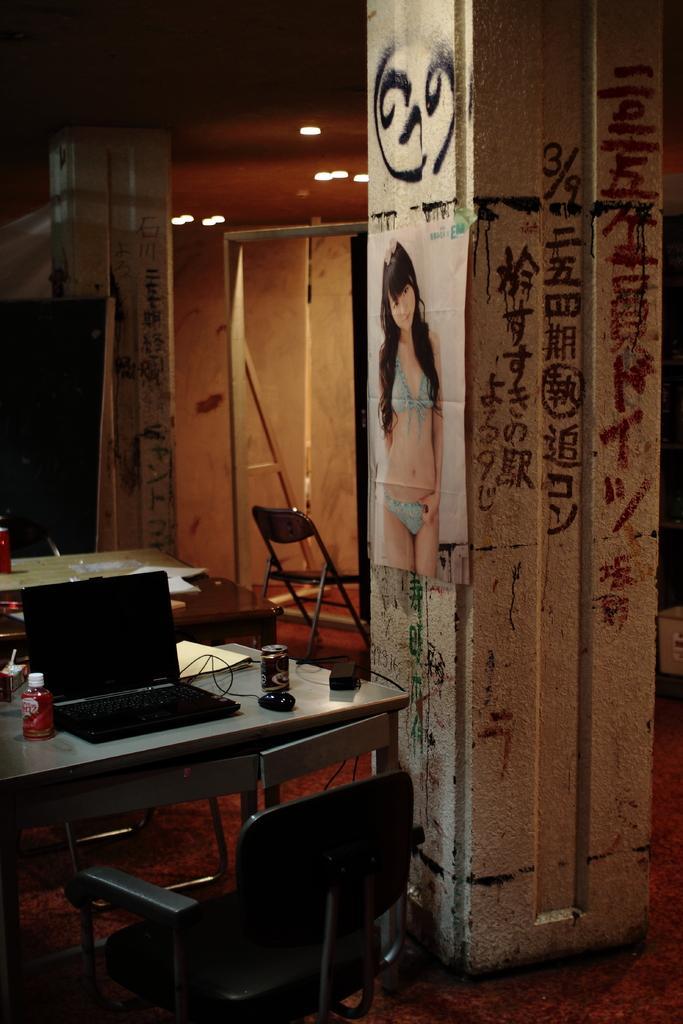Could you give a brief overview of what you see in this image? In this image, in the left side there is a table which is in white color, on that table there is a laptop which is in black color, there is a red color bottle, there is a chair which is in black color, in the right side there is a wall which is in white color on that wall there is a girl picture pasted, in the background there is a white color wall and there are some light in the top in yellow color. 